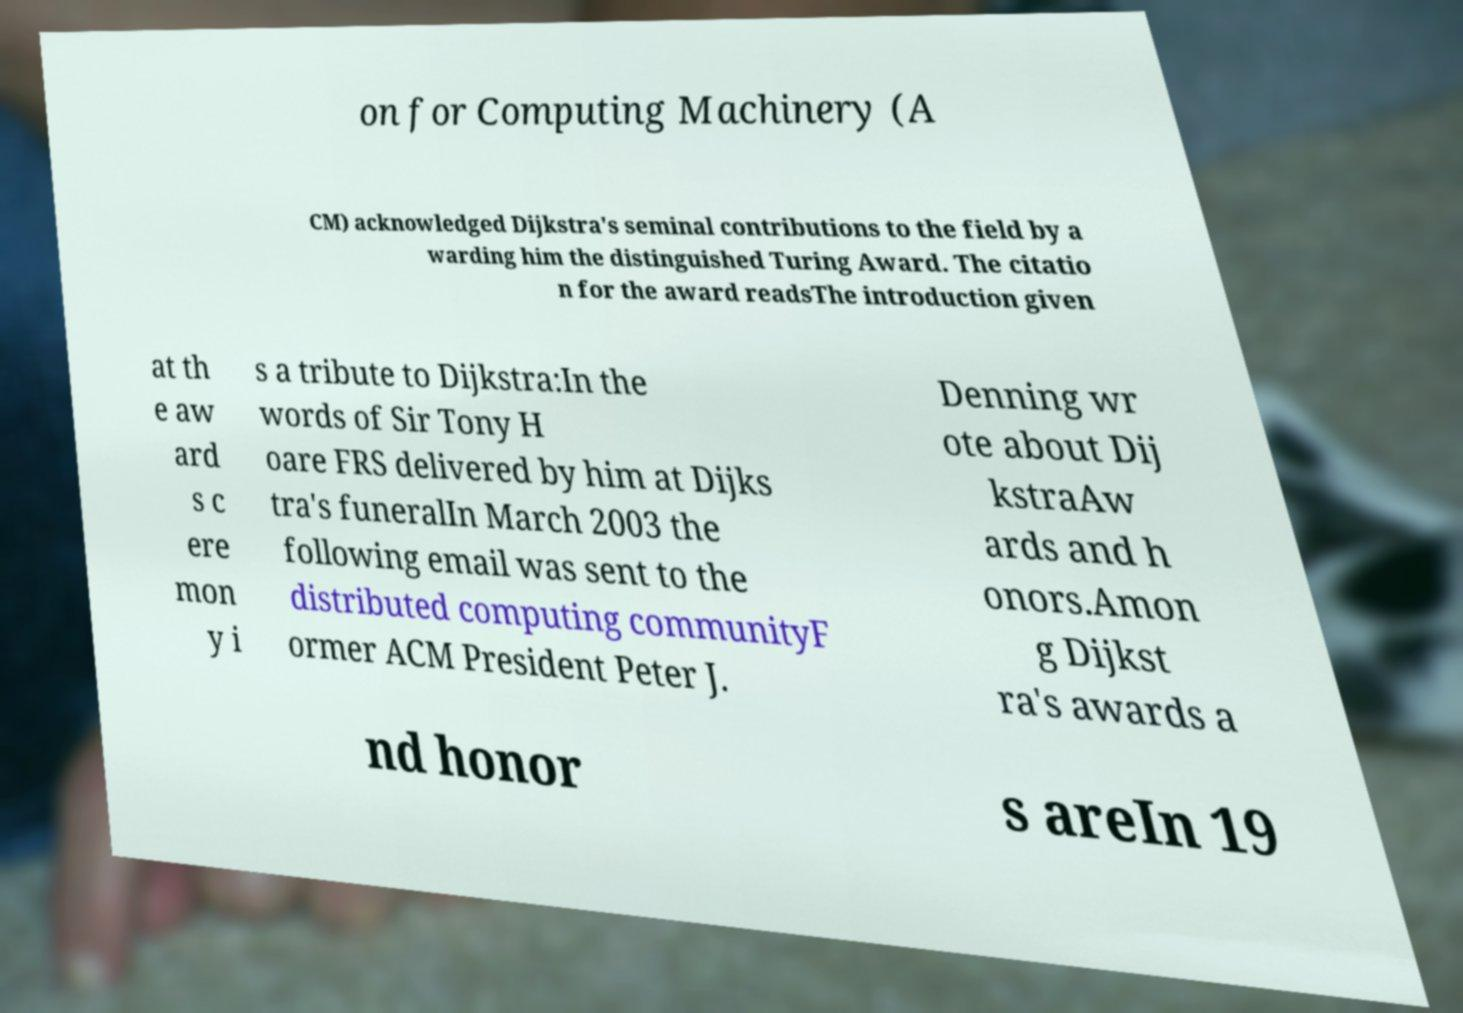Please read and relay the text visible in this image. What does it say? on for Computing Machinery (A CM) acknowledged Dijkstra's seminal contributions to the field by a warding him the distinguished Turing Award. The citatio n for the award readsThe introduction given at th e aw ard s c ere mon y i s a tribute to Dijkstra:In the words of Sir Tony H oare FRS delivered by him at Dijks tra's funeralIn March 2003 the following email was sent to the distributed computing communityF ormer ACM President Peter J. Denning wr ote about Dij kstraAw ards and h onors.Amon g Dijkst ra's awards a nd honor s areIn 19 